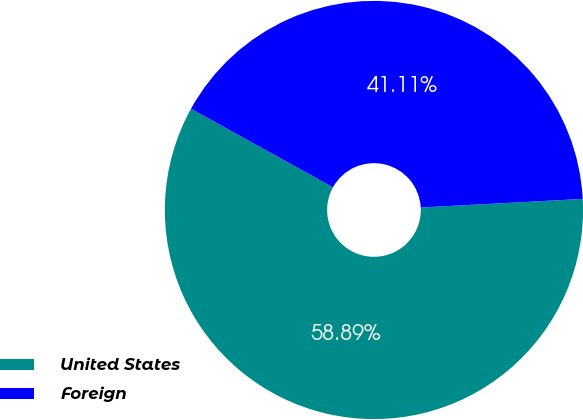Convert chart to OTSL. <chart><loc_0><loc_0><loc_500><loc_500><pie_chart><fcel>United States<fcel>Foreign<nl><fcel>58.89%<fcel>41.11%<nl></chart> 